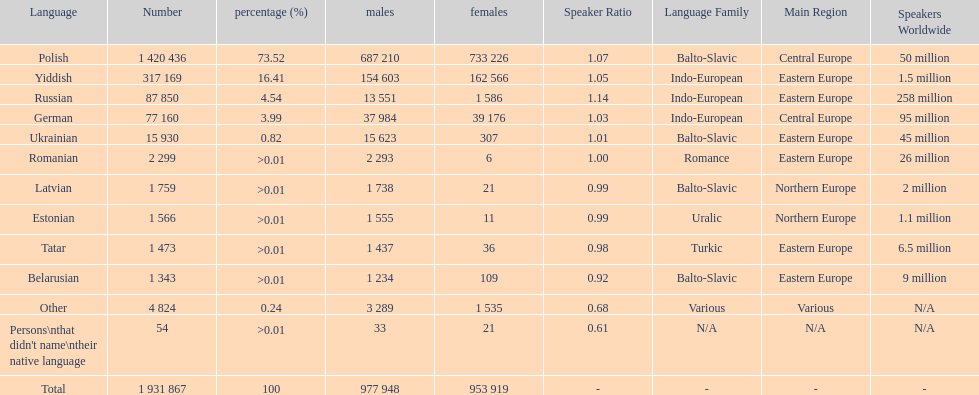What was the second most frequently spoken language in poland after russian? German. 